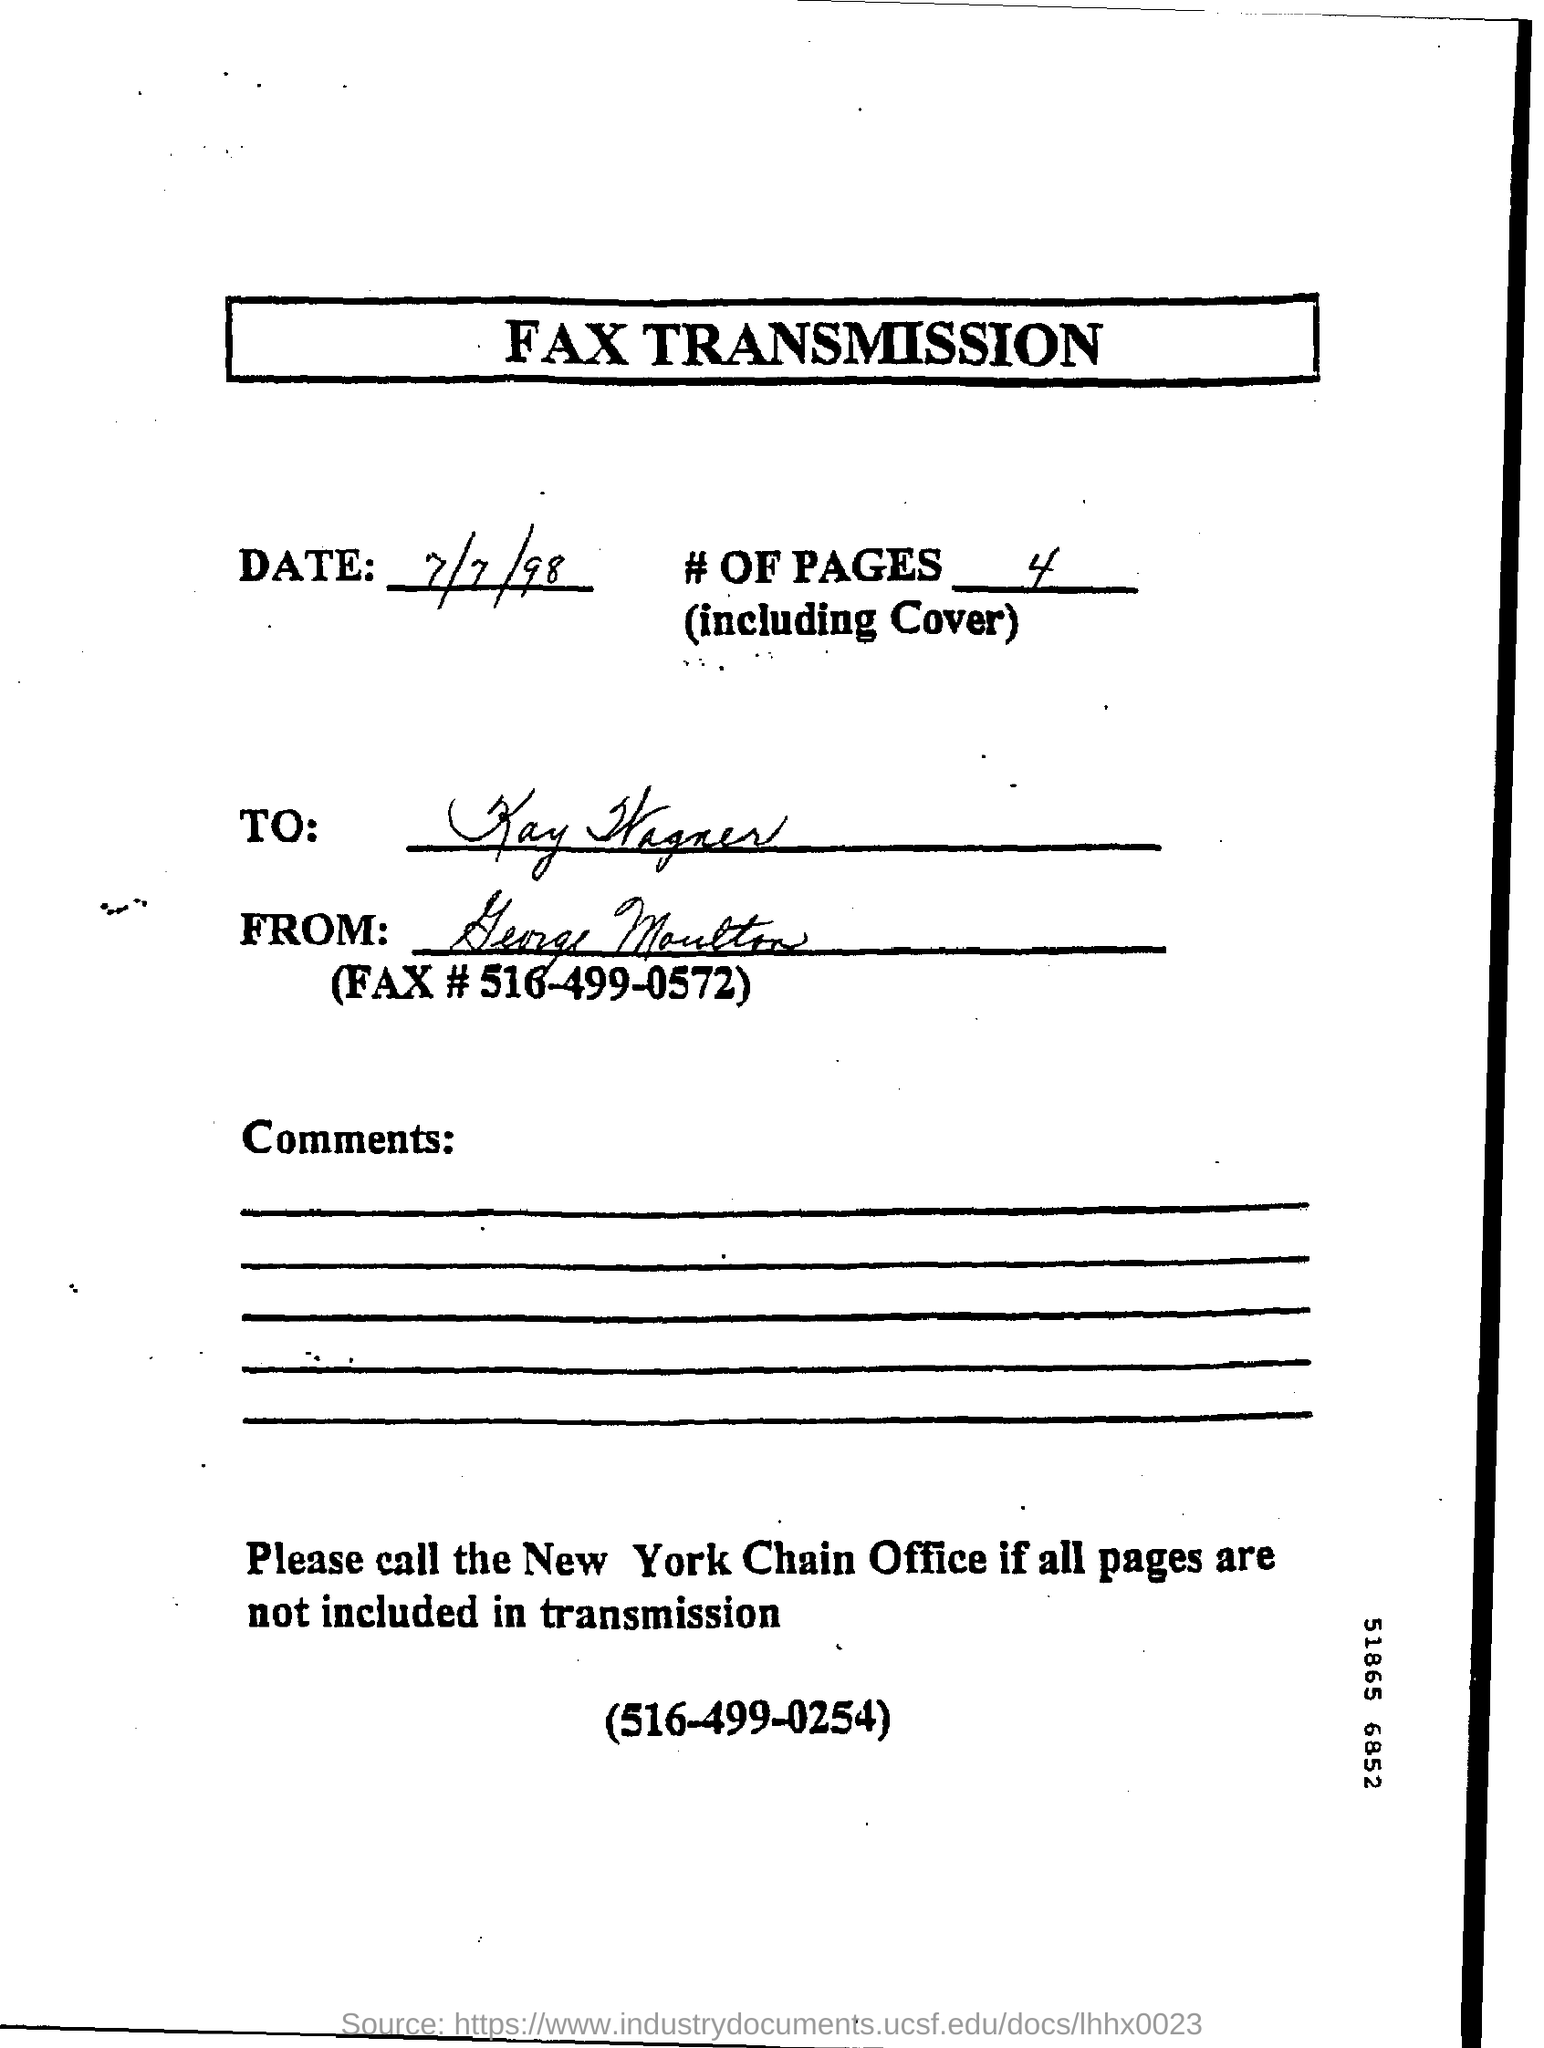Point out several critical features in this image. The date mentioned in the letter is 7/7/98. The fax number is 516-499-0572. The to address is Kay Wagner. 